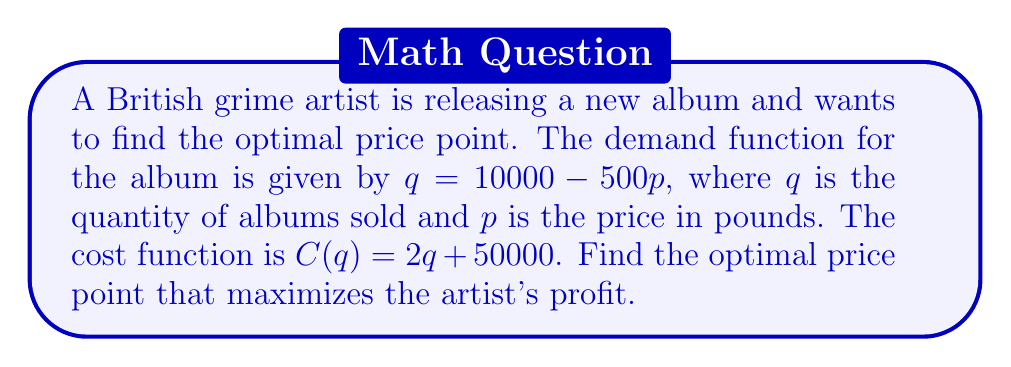Show me your answer to this math problem. To find the optimal price point, we need to follow these steps:

1) First, let's express the revenue function in terms of $p$:
   $R = pq = p(10000 - 500p) = 10000p - 500p^2$

2) The cost function in terms of $p$ is:
   $C = 2(10000 - 500p) + 50000 = 70000 - 1000p$

3) The profit function is revenue minus cost:
   $P = R - C = (10000p - 500p^2) - (70000 - 1000p)$
   $P = 10000p - 500p^2 - 70000 + 1000p$
   $P = 11000p - 500p^2 - 70000$

4) To find the maximum profit, we differentiate $P$ with respect to $p$ and set it to zero:
   $$\frac{dP}{dp} = 11000 - 1000p = 0$$

5) Solving this equation:
   $11000 - 1000p = 0$
   $1000p = 11000$
   $p = 11$

6) To confirm this is a maximum, we can check the second derivative:
   $$\frac{d^2P}{dp^2} = -1000 < 0$$
   This confirms that $p = 11$ gives a maximum.

Therefore, the optimal price point is £11.
Answer: The optimal price point that maximizes the artist's profit is £11. 